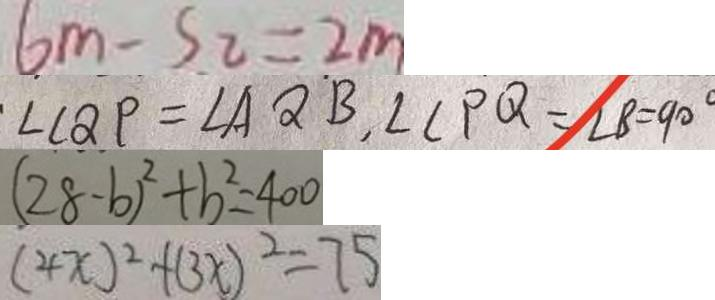<formula> <loc_0><loc_0><loc_500><loc_500>6 m - S _ { 2 } = 2 m 
 \cdot \angle C Q P = \angle A Q B , \angle C P Q = \angle B = 9 0 ^ { \circ } 
 ( 2 8 - b ) ^ { 2 } + b ^ { 2 } = 4 0 0 
 ( 4 x ) ^ { 2 } + ( 3 x ) ^ { 2 } = 7 5</formula> 